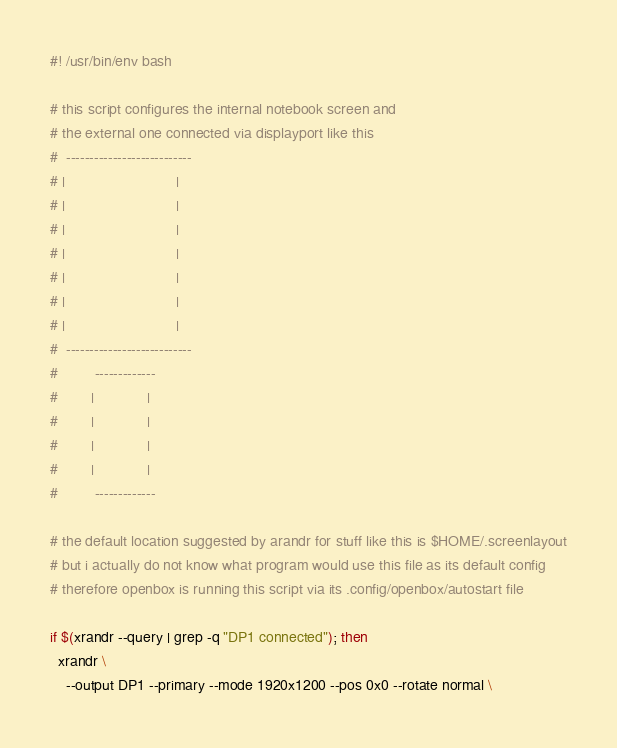<code> <loc_0><loc_0><loc_500><loc_500><_Bash_>#! /usr/bin/env bash

# this script configures the internal notebook screen and
# the external one connected via displayport like this
#  --------------------------- 
# |                           |
# |                           |
# |                           |
# |                           |
# |                           |
# |                           |
# |                           |
#  ---------------------------
#         -------------
#        |             |
#        |             |
#        |             |
#        |             |
#         -------------

# the default location suggested by arandr for stuff like this is $HOME/.screenlayout
# but i actually do not know what program would use this file as its default config
# therefore openbox is running this script via its .config/openbox/autostart file

if $(xrandr --query | grep -q "DP1 connected"); then
  xrandr \
    --output DP1 --primary --mode 1920x1200 --pos 0x0 --rotate normal \</code> 